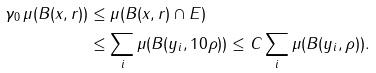<formula> <loc_0><loc_0><loc_500><loc_500>\gamma _ { 0 } \, \mu ( B ( x , r ) ) & \leq \mu ( B ( x , r ) \cap E ) \\ & \leq \sum _ { i } \mu ( B ( y _ { i } , 1 0 \rho ) ) \leq C \sum _ { i } \mu ( B ( y _ { i } , \rho ) ) .</formula> 